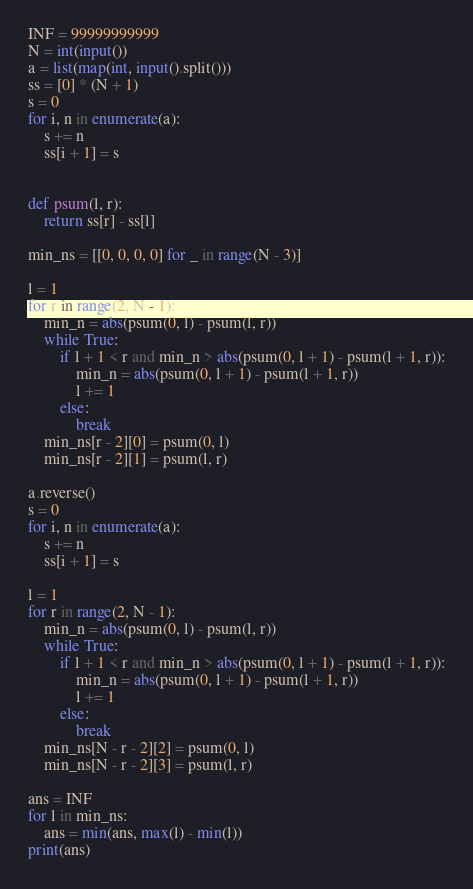<code> <loc_0><loc_0><loc_500><loc_500><_Python_>INF = 99999999999
N = int(input())
a = list(map(int, input().split()))
ss = [0] * (N + 1)
s = 0
for i, n in enumerate(a):
    s += n
    ss[i + 1] = s


def psum(l, r):
    return ss[r] - ss[l]

min_ns = [[0, 0, 0, 0] for _ in range(N - 3)]

l = 1
for r in range(2, N - 1):
    min_n = abs(psum(0, l) - psum(l, r))
    while True:
        if l + 1 < r and min_n > abs(psum(0, l + 1) - psum(l + 1, r)):
            min_n = abs(psum(0, l + 1) - psum(l + 1, r))
            l += 1
        else:
            break
    min_ns[r - 2][0] = psum(0, l)
    min_ns[r - 2][1] = psum(l, r)

a.reverse()
s = 0
for i, n in enumerate(a):
    s += n
    ss[i + 1] = s

l = 1
for r in range(2, N - 1):
    min_n = abs(psum(0, l) - psum(l, r))
    while True:
        if l + 1 < r and min_n > abs(psum(0, l + 1) - psum(l + 1, r)):
            min_n = abs(psum(0, l + 1) - psum(l + 1, r))
            l += 1
        else:
            break
    min_ns[N - r - 2][2] = psum(0, l)
    min_ns[N - r - 2][3] = psum(l, r)

ans = INF
for l in min_ns:
    ans = min(ans, max(l) - min(l))
print(ans)
</code> 